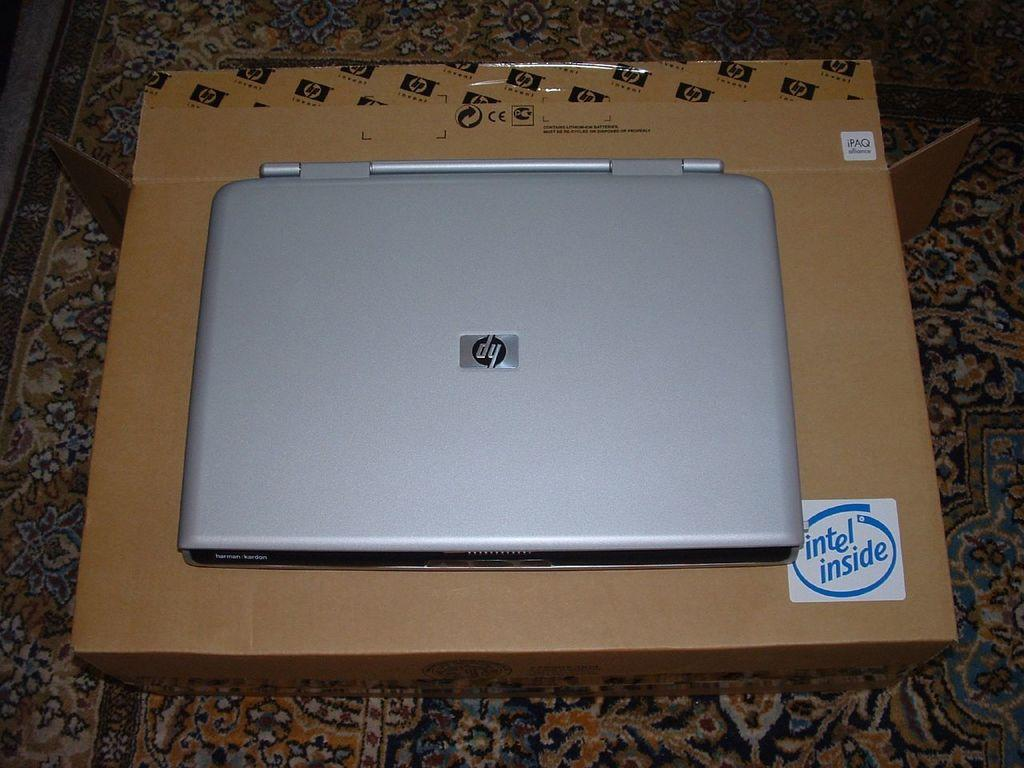What is the main object in the center of the image? There is a carpet in the center of the image. What is placed on the carpet? There is a box on the carpet. What is on top of the box? There is a laptop on the box. What can be read on the box? There is text visible on the box. What type of sleet can be seen falling on the laptop in the image? There is no sleet present in the image; it is an indoor setting with a laptop on a box. Can you tell me how many faucets are visible in the image? There are no faucets present in the image; it features a carpet, a box, and a laptop. 